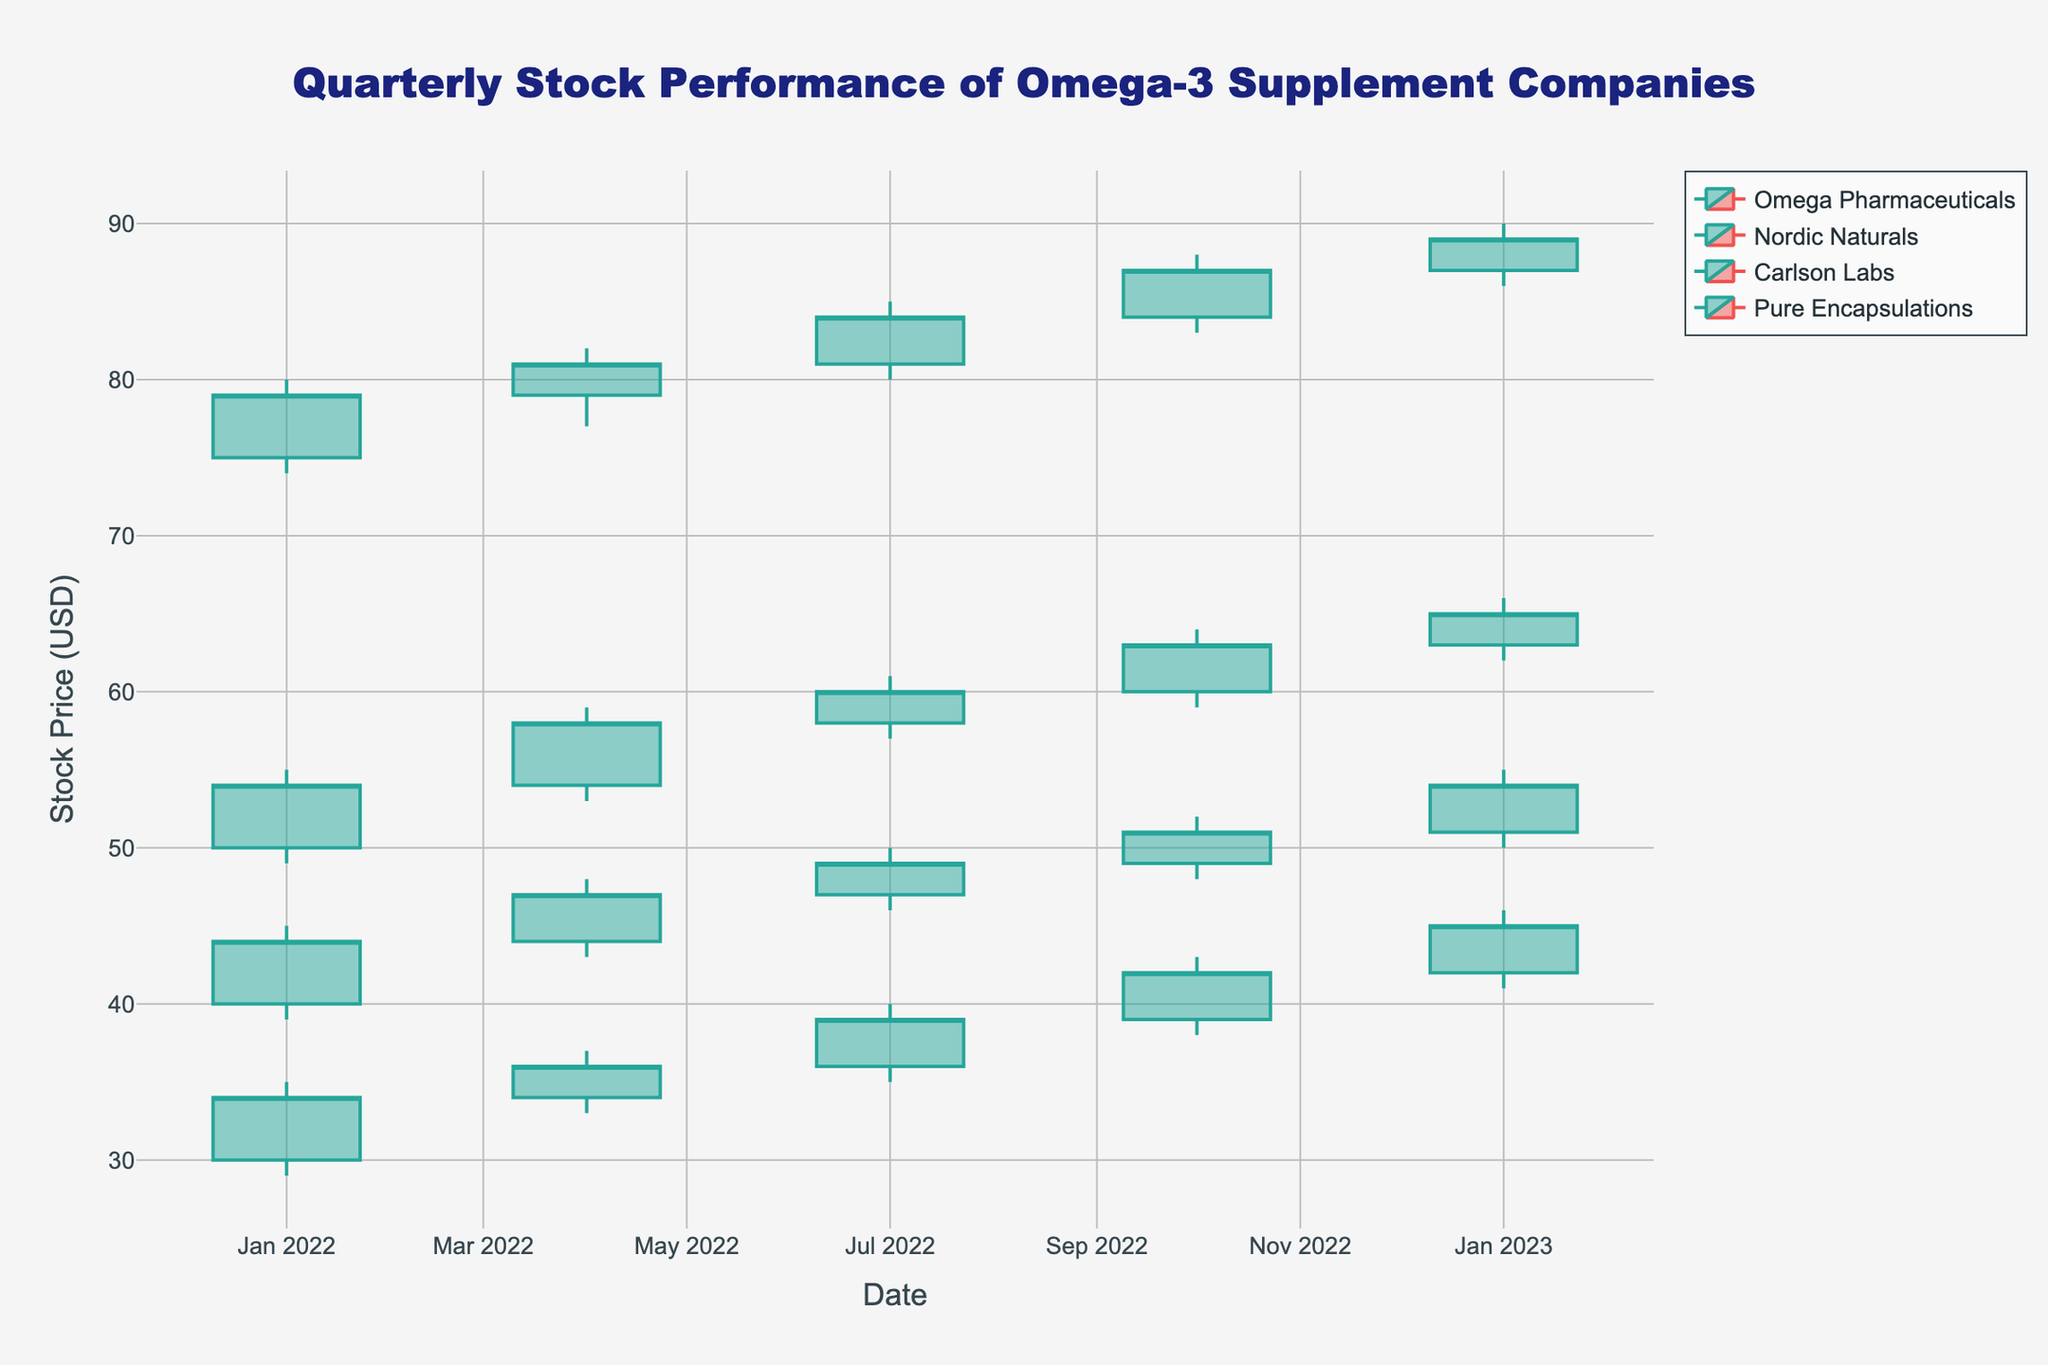What is the title of the figure? The figure title is usually displayed prominently at the top. The title of this figure is "Quarterly Stock Performance of Omega-3 Supplement Companies."
Answer: Quarterly Stock Performance of Omega-3 Supplement Companies What is the highest closing price for Omega Pharmaceuticals in 2022? The figure shows the quarterly stock data for each company. For Omega Pharmaceuticals in 2022, the highest closing price is 63.00, which occurred in Q4 (October to December).
Answer: 63.00 Which company had the highest stock price in Q1 2023? To determine this, check the "High" column for Q1 2023 for each company. Nordic Naturals had the highest stock price of 90.00 in Q1 2023.
Answer: Nordic Naturals How did Carlson Labs' stock closing price change from Q1 2022 to Q1 2023? Compare the closing prices for Carlson Labs between Q1 2022 (44.00) and Q1 2023 (54.00). The stock increased by 10.00.
Answer: Increased by 10.00 On which quarter did Pure Encapsulations see the highest "High" price in 2022? Examine each quarter's "High" prices for Pure Encapsulations in 2022. The highest "High" price of 43.00 was in Q4 (October to December).
Answer: Q4 (October to December) What is the pattern of trade volume for Nordic Naturals throughout 2022? Inspect the volume data for Nordic Naturals for each quarter in 2022. The volumes are 980000, 950000, 1020000, and 1100000. This shows a fluctuating trend, starting higher in Q1, dropping in Q2, and then gradually increasing in Q3 and Q4.
Answer: Fluctuating with an increasing trend in the latter half 